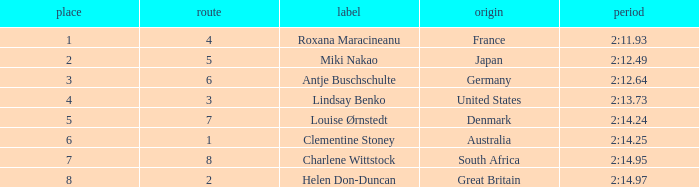What shows for nationality when there is a rank larger than 6, and a Time of 2:14.95? South Africa. 